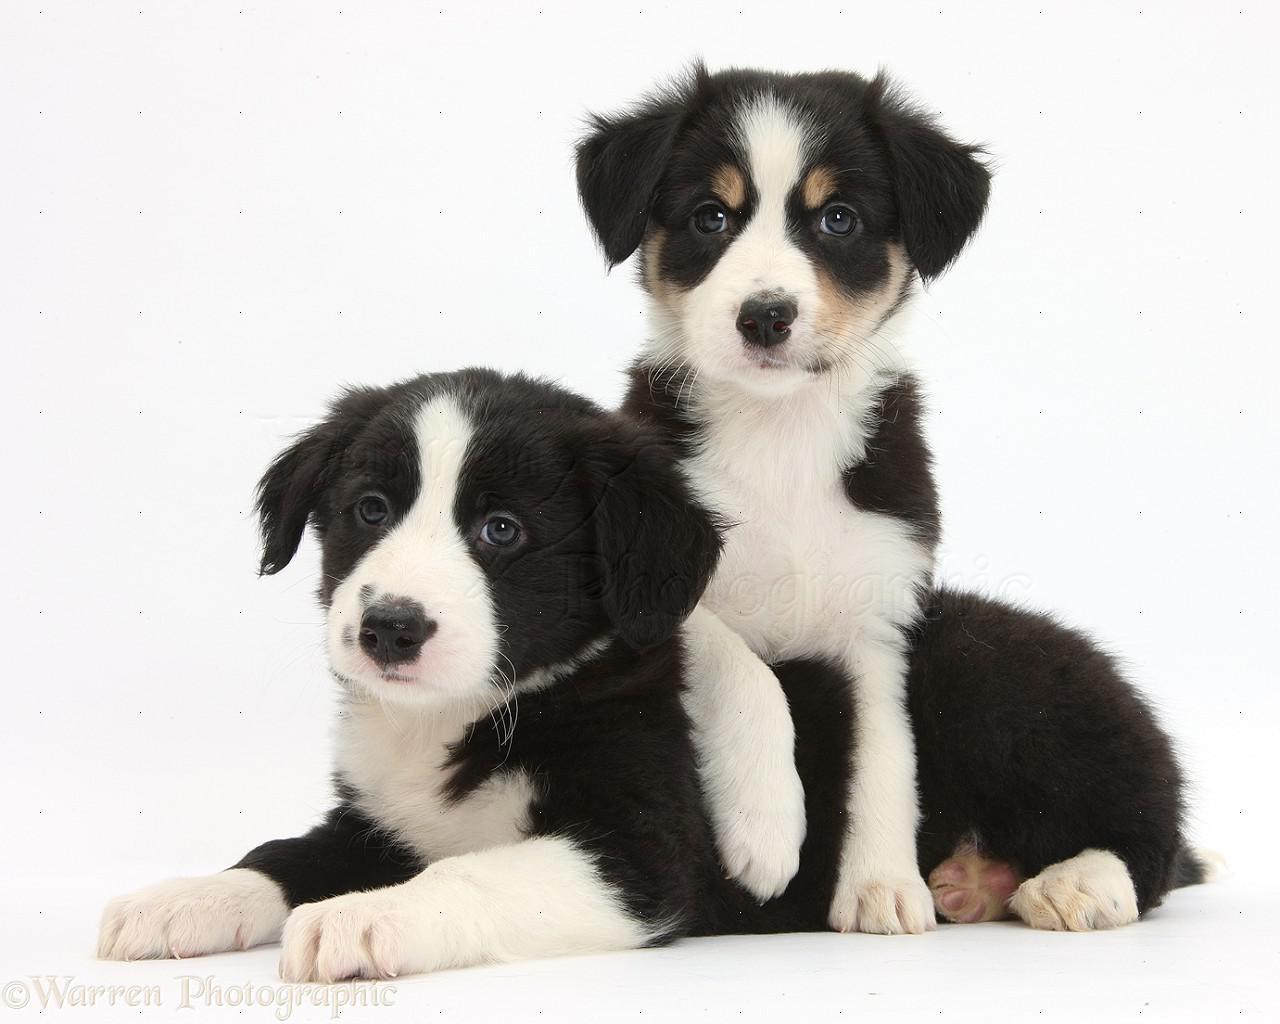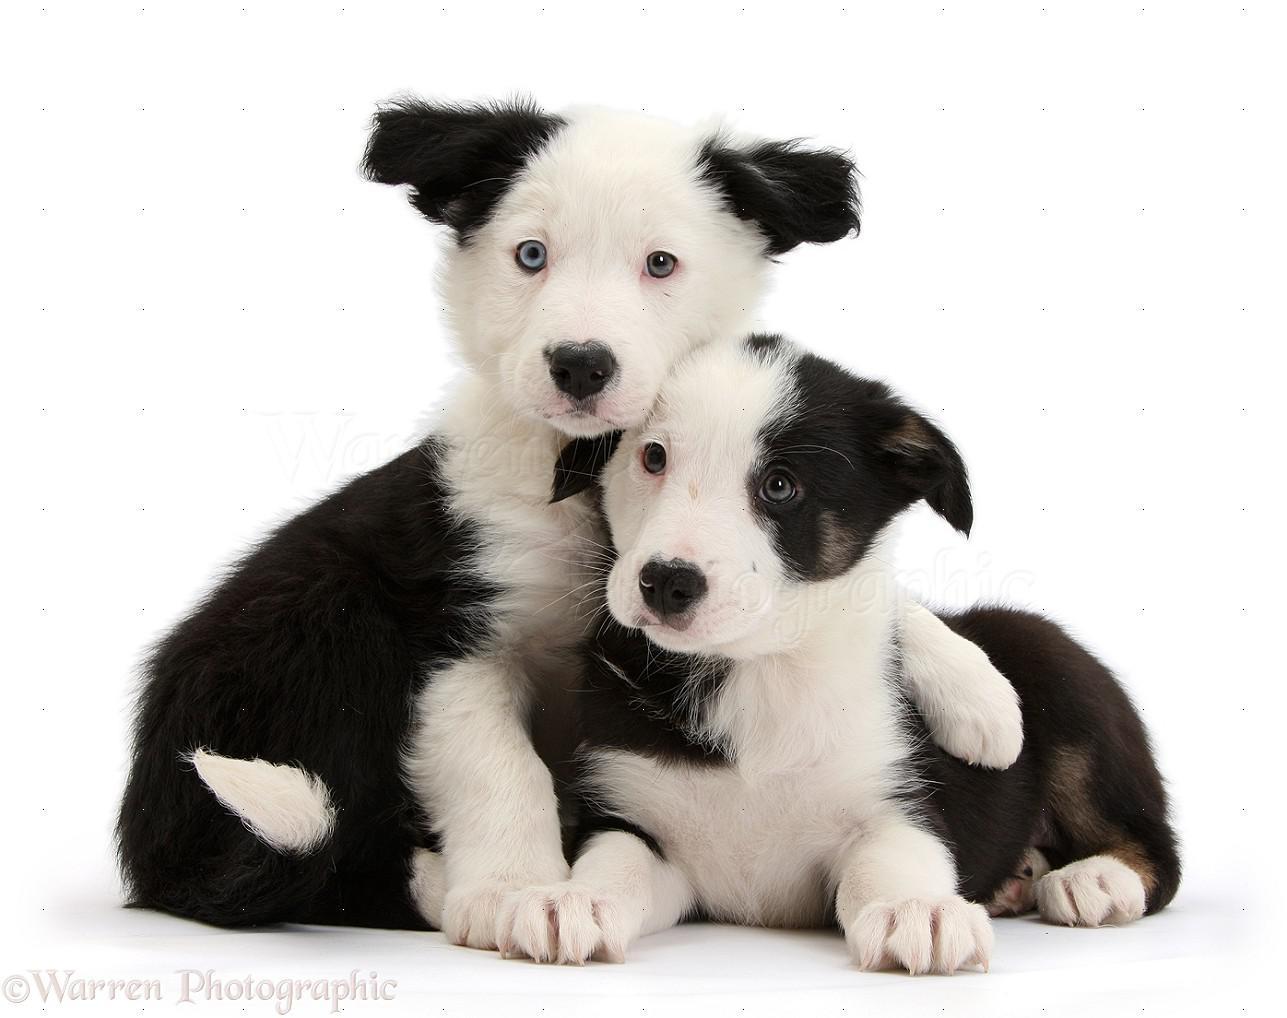The first image is the image on the left, the second image is the image on the right. Given the left and right images, does the statement "Both images contain only one dog." hold true? Answer yes or no. No. The first image is the image on the left, the second image is the image on the right. Evaluate the accuracy of this statement regarding the images: "There are four puppies in the pair of images.". Is it true? Answer yes or no. Yes. 